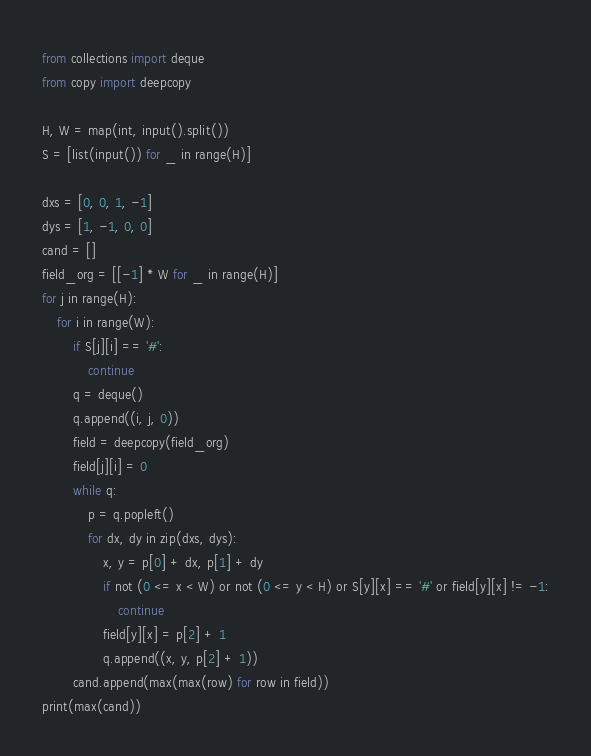Convert code to text. <code><loc_0><loc_0><loc_500><loc_500><_Python_>from collections import deque
from copy import deepcopy

H, W = map(int, input().split())
S = [list(input()) for _ in range(H)]

dxs = [0, 0, 1, -1]
dys = [1, -1, 0, 0]
cand = []
field_org = [[-1] * W for _ in range(H)]
for j in range(H):
    for i in range(W):
        if S[j][i] == '#':
            continue
        q = deque()
        q.append((i, j, 0))
        field = deepcopy(field_org)
        field[j][i] = 0
        while q:
            p = q.popleft()
            for dx, dy in zip(dxs, dys):
                x, y = p[0] + dx, p[1] + dy
                if not (0 <= x < W) or not (0 <= y < H) or S[y][x] == '#' or field[y][x] != -1:
                    continue
                field[y][x] = p[2] + 1
                q.append((x, y, p[2] + 1))
        cand.append(max(max(row) for row in field))
print(max(cand))</code> 